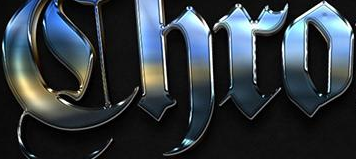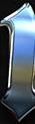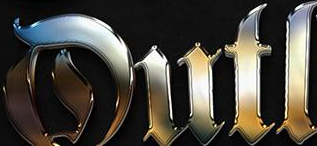Transcribe the words shown in these images in order, separated by a semicolon. Chro; #; Dutl 